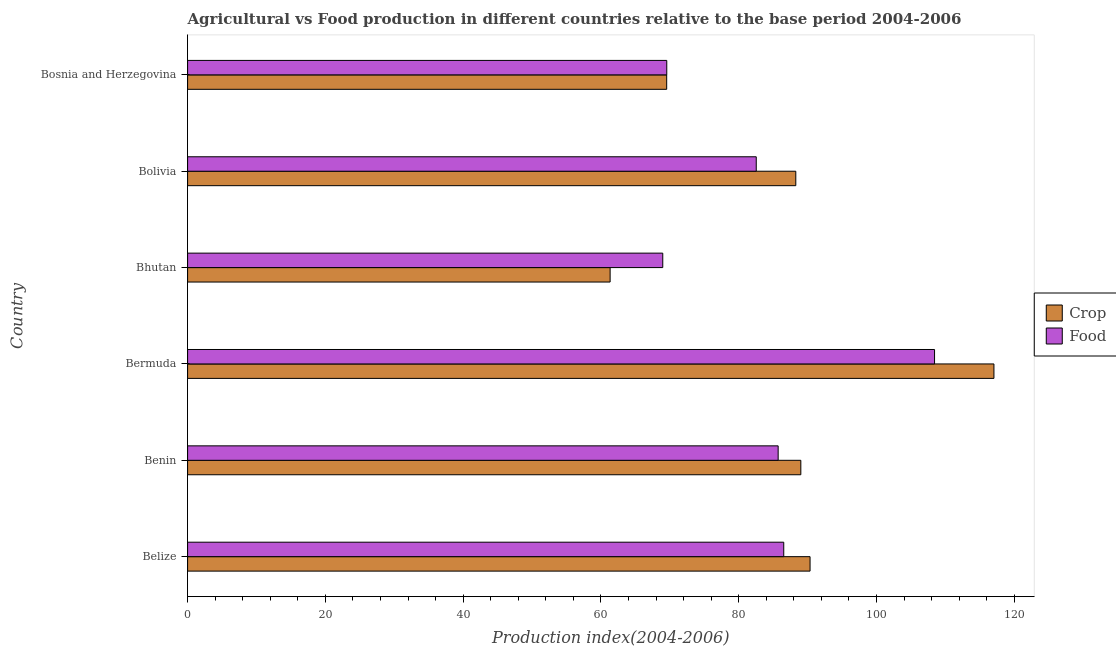How many different coloured bars are there?
Make the answer very short. 2. Are the number of bars on each tick of the Y-axis equal?
Offer a terse response. Yes. How many bars are there on the 4th tick from the top?
Make the answer very short. 2. What is the label of the 5th group of bars from the top?
Make the answer very short. Benin. What is the crop production index in Bermuda?
Make the answer very short. 117.04. Across all countries, what is the maximum crop production index?
Your response must be concise. 117.04. Across all countries, what is the minimum crop production index?
Make the answer very short. 61.33. In which country was the crop production index maximum?
Provide a short and direct response. Bermuda. In which country was the food production index minimum?
Ensure brevity in your answer.  Bhutan. What is the total crop production index in the graph?
Offer a very short reply. 515.55. What is the difference between the crop production index in Benin and that in Bhutan?
Provide a short and direct response. 27.68. What is the difference between the food production index in Benin and the crop production index in Bolivia?
Your response must be concise. -2.56. What is the average food production index per country?
Provide a succinct answer. 83.62. What is the difference between the crop production index and food production index in Bhutan?
Offer a terse response. -7.64. What is the ratio of the food production index in Benin to that in Bolivia?
Offer a terse response. 1.04. Is the crop production index in Benin less than that in Bolivia?
Make the answer very short. No. What is the difference between the highest and the second highest crop production index?
Provide a succinct answer. 26.69. What is the difference between the highest and the lowest crop production index?
Give a very brief answer. 55.71. What does the 1st bar from the top in Bolivia represents?
Ensure brevity in your answer.  Food. What does the 1st bar from the bottom in Benin represents?
Provide a short and direct response. Crop. Does the graph contain any zero values?
Offer a terse response. No. Does the graph contain grids?
Keep it short and to the point. No. Where does the legend appear in the graph?
Ensure brevity in your answer.  Center right. How many legend labels are there?
Offer a very short reply. 2. How are the legend labels stacked?
Offer a terse response. Vertical. What is the title of the graph?
Provide a short and direct response. Agricultural vs Food production in different countries relative to the base period 2004-2006. Does "Depositors" appear as one of the legend labels in the graph?
Offer a very short reply. No. What is the label or title of the X-axis?
Your answer should be very brief. Production index(2004-2006). What is the label or title of the Y-axis?
Make the answer very short. Country. What is the Production index(2004-2006) of Crop in Belize?
Ensure brevity in your answer.  90.35. What is the Production index(2004-2006) in Food in Belize?
Offer a very short reply. 86.53. What is the Production index(2004-2006) in Crop in Benin?
Keep it short and to the point. 89.01. What is the Production index(2004-2006) in Food in Benin?
Provide a succinct answer. 85.72. What is the Production index(2004-2006) of Crop in Bermuda?
Your answer should be very brief. 117.04. What is the Production index(2004-2006) of Food in Bermuda?
Your answer should be very brief. 108.42. What is the Production index(2004-2006) in Crop in Bhutan?
Provide a short and direct response. 61.33. What is the Production index(2004-2006) of Food in Bhutan?
Your answer should be very brief. 68.97. What is the Production index(2004-2006) of Crop in Bolivia?
Ensure brevity in your answer.  88.28. What is the Production index(2004-2006) of Food in Bolivia?
Your answer should be very brief. 82.54. What is the Production index(2004-2006) in Crop in Bosnia and Herzegovina?
Your response must be concise. 69.54. What is the Production index(2004-2006) in Food in Bosnia and Herzegovina?
Keep it short and to the point. 69.55. Across all countries, what is the maximum Production index(2004-2006) of Crop?
Keep it short and to the point. 117.04. Across all countries, what is the maximum Production index(2004-2006) of Food?
Your response must be concise. 108.42. Across all countries, what is the minimum Production index(2004-2006) in Crop?
Make the answer very short. 61.33. Across all countries, what is the minimum Production index(2004-2006) in Food?
Offer a terse response. 68.97. What is the total Production index(2004-2006) in Crop in the graph?
Keep it short and to the point. 515.55. What is the total Production index(2004-2006) in Food in the graph?
Provide a short and direct response. 501.73. What is the difference between the Production index(2004-2006) in Crop in Belize and that in Benin?
Your answer should be compact. 1.34. What is the difference between the Production index(2004-2006) of Food in Belize and that in Benin?
Make the answer very short. 0.81. What is the difference between the Production index(2004-2006) in Crop in Belize and that in Bermuda?
Offer a very short reply. -26.69. What is the difference between the Production index(2004-2006) in Food in Belize and that in Bermuda?
Offer a terse response. -21.89. What is the difference between the Production index(2004-2006) of Crop in Belize and that in Bhutan?
Provide a short and direct response. 29.02. What is the difference between the Production index(2004-2006) in Food in Belize and that in Bhutan?
Offer a very short reply. 17.56. What is the difference between the Production index(2004-2006) of Crop in Belize and that in Bolivia?
Provide a short and direct response. 2.07. What is the difference between the Production index(2004-2006) of Food in Belize and that in Bolivia?
Your response must be concise. 3.99. What is the difference between the Production index(2004-2006) of Crop in Belize and that in Bosnia and Herzegovina?
Provide a succinct answer. 20.81. What is the difference between the Production index(2004-2006) in Food in Belize and that in Bosnia and Herzegovina?
Your response must be concise. 16.98. What is the difference between the Production index(2004-2006) of Crop in Benin and that in Bermuda?
Provide a short and direct response. -28.03. What is the difference between the Production index(2004-2006) of Food in Benin and that in Bermuda?
Ensure brevity in your answer.  -22.7. What is the difference between the Production index(2004-2006) in Crop in Benin and that in Bhutan?
Offer a very short reply. 27.68. What is the difference between the Production index(2004-2006) of Food in Benin and that in Bhutan?
Give a very brief answer. 16.75. What is the difference between the Production index(2004-2006) of Crop in Benin and that in Bolivia?
Provide a succinct answer. 0.73. What is the difference between the Production index(2004-2006) of Food in Benin and that in Bolivia?
Make the answer very short. 3.18. What is the difference between the Production index(2004-2006) of Crop in Benin and that in Bosnia and Herzegovina?
Keep it short and to the point. 19.47. What is the difference between the Production index(2004-2006) of Food in Benin and that in Bosnia and Herzegovina?
Offer a very short reply. 16.17. What is the difference between the Production index(2004-2006) in Crop in Bermuda and that in Bhutan?
Make the answer very short. 55.71. What is the difference between the Production index(2004-2006) in Food in Bermuda and that in Bhutan?
Your answer should be very brief. 39.45. What is the difference between the Production index(2004-2006) of Crop in Bermuda and that in Bolivia?
Your response must be concise. 28.76. What is the difference between the Production index(2004-2006) in Food in Bermuda and that in Bolivia?
Your response must be concise. 25.88. What is the difference between the Production index(2004-2006) in Crop in Bermuda and that in Bosnia and Herzegovina?
Give a very brief answer. 47.5. What is the difference between the Production index(2004-2006) in Food in Bermuda and that in Bosnia and Herzegovina?
Your response must be concise. 38.87. What is the difference between the Production index(2004-2006) of Crop in Bhutan and that in Bolivia?
Provide a succinct answer. -26.95. What is the difference between the Production index(2004-2006) in Food in Bhutan and that in Bolivia?
Your response must be concise. -13.57. What is the difference between the Production index(2004-2006) in Crop in Bhutan and that in Bosnia and Herzegovina?
Ensure brevity in your answer.  -8.21. What is the difference between the Production index(2004-2006) in Food in Bhutan and that in Bosnia and Herzegovina?
Offer a very short reply. -0.58. What is the difference between the Production index(2004-2006) of Crop in Bolivia and that in Bosnia and Herzegovina?
Your answer should be compact. 18.74. What is the difference between the Production index(2004-2006) in Food in Bolivia and that in Bosnia and Herzegovina?
Keep it short and to the point. 12.99. What is the difference between the Production index(2004-2006) in Crop in Belize and the Production index(2004-2006) in Food in Benin?
Your response must be concise. 4.63. What is the difference between the Production index(2004-2006) of Crop in Belize and the Production index(2004-2006) of Food in Bermuda?
Make the answer very short. -18.07. What is the difference between the Production index(2004-2006) in Crop in Belize and the Production index(2004-2006) in Food in Bhutan?
Your response must be concise. 21.38. What is the difference between the Production index(2004-2006) in Crop in Belize and the Production index(2004-2006) in Food in Bolivia?
Offer a terse response. 7.81. What is the difference between the Production index(2004-2006) in Crop in Belize and the Production index(2004-2006) in Food in Bosnia and Herzegovina?
Give a very brief answer. 20.8. What is the difference between the Production index(2004-2006) of Crop in Benin and the Production index(2004-2006) of Food in Bermuda?
Your response must be concise. -19.41. What is the difference between the Production index(2004-2006) of Crop in Benin and the Production index(2004-2006) of Food in Bhutan?
Your answer should be very brief. 20.04. What is the difference between the Production index(2004-2006) of Crop in Benin and the Production index(2004-2006) of Food in Bolivia?
Provide a succinct answer. 6.47. What is the difference between the Production index(2004-2006) of Crop in Benin and the Production index(2004-2006) of Food in Bosnia and Herzegovina?
Your response must be concise. 19.46. What is the difference between the Production index(2004-2006) in Crop in Bermuda and the Production index(2004-2006) in Food in Bhutan?
Your answer should be compact. 48.07. What is the difference between the Production index(2004-2006) in Crop in Bermuda and the Production index(2004-2006) in Food in Bolivia?
Offer a terse response. 34.5. What is the difference between the Production index(2004-2006) in Crop in Bermuda and the Production index(2004-2006) in Food in Bosnia and Herzegovina?
Your response must be concise. 47.49. What is the difference between the Production index(2004-2006) in Crop in Bhutan and the Production index(2004-2006) in Food in Bolivia?
Your answer should be very brief. -21.21. What is the difference between the Production index(2004-2006) of Crop in Bhutan and the Production index(2004-2006) of Food in Bosnia and Herzegovina?
Offer a very short reply. -8.22. What is the difference between the Production index(2004-2006) in Crop in Bolivia and the Production index(2004-2006) in Food in Bosnia and Herzegovina?
Your answer should be very brief. 18.73. What is the average Production index(2004-2006) of Crop per country?
Make the answer very short. 85.92. What is the average Production index(2004-2006) of Food per country?
Offer a very short reply. 83.62. What is the difference between the Production index(2004-2006) of Crop and Production index(2004-2006) of Food in Belize?
Offer a terse response. 3.82. What is the difference between the Production index(2004-2006) of Crop and Production index(2004-2006) of Food in Benin?
Provide a short and direct response. 3.29. What is the difference between the Production index(2004-2006) in Crop and Production index(2004-2006) in Food in Bermuda?
Offer a very short reply. 8.62. What is the difference between the Production index(2004-2006) in Crop and Production index(2004-2006) in Food in Bhutan?
Provide a succinct answer. -7.64. What is the difference between the Production index(2004-2006) in Crop and Production index(2004-2006) in Food in Bolivia?
Offer a very short reply. 5.74. What is the difference between the Production index(2004-2006) of Crop and Production index(2004-2006) of Food in Bosnia and Herzegovina?
Make the answer very short. -0.01. What is the ratio of the Production index(2004-2006) of Crop in Belize to that in Benin?
Keep it short and to the point. 1.02. What is the ratio of the Production index(2004-2006) of Food in Belize to that in Benin?
Give a very brief answer. 1.01. What is the ratio of the Production index(2004-2006) of Crop in Belize to that in Bermuda?
Your answer should be very brief. 0.77. What is the ratio of the Production index(2004-2006) in Food in Belize to that in Bermuda?
Provide a short and direct response. 0.8. What is the ratio of the Production index(2004-2006) in Crop in Belize to that in Bhutan?
Ensure brevity in your answer.  1.47. What is the ratio of the Production index(2004-2006) in Food in Belize to that in Bhutan?
Provide a succinct answer. 1.25. What is the ratio of the Production index(2004-2006) of Crop in Belize to that in Bolivia?
Your answer should be very brief. 1.02. What is the ratio of the Production index(2004-2006) of Food in Belize to that in Bolivia?
Make the answer very short. 1.05. What is the ratio of the Production index(2004-2006) of Crop in Belize to that in Bosnia and Herzegovina?
Keep it short and to the point. 1.3. What is the ratio of the Production index(2004-2006) of Food in Belize to that in Bosnia and Herzegovina?
Ensure brevity in your answer.  1.24. What is the ratio of the Production index(2004-2006) of Crop in Benin to that in Bermuda?
Keep it short and to the point. 0.76. What is the ratio of the Production index(2004-2006) of Food in Benin to that in Bermuda?
Make the answer very short. 0.79. What is the ratio of the Production index(2004-2006) in Crop in Benin to that in Bhutan?
Ensure brevity in your answer.  1.45. What is the ratio of the Production index(2004-2006) of Food in Benin to that in Bhutan?
Ensure brevity in your answer.  1.24. What is the ratio of the Production index(2004-2006) of Crop in Benin to that in Bolivia?
Offer a very short reply. 1.01. What is the ratio of the Production index(2004-2006) in Crop in Benin to that in Bosnia and Herzegovina?
Your answer should be very brief. 1.28. What is the ratio of the Production index(2004-2006) in Food in Benin to that in Bosnia and Herzegovina?
Provide a short and direct response. 1.23. What is the ratio of the Production index(2004-2006) of Crop in Bermuda to that in Bhutan?
Provide a short and direct response. 1.91. What is the ratio of the Production index(2004-2006) in Food in Bermuda to that in Bhutan?
Make the answer very short. 1.57. What is the ratio of the Production index(2004-2006) in Crop in Bermuda to that in Bolivia?
Make the answer very short. 1.33. What is the ratio of the Production index(2004-2006) of Food in Bermuda to that in Bolivia?
Provide a short and direct response. 1.31. What is the ratio of the Production index(2004-2006) of Crop in Bermuda to that in Bosnia and Herzegovina?
Provide a short and direct response. 1.68. What is the ratio of the Production index(2004-2006) of Food in Bermuda to that in Bosnia and Herzegovina?
Your answer should be compact. 1.56. What is the ratio of the Production index(2004-2006) in Crop in Bhutan to that in Bolivia?
Provide a succinct answer. 0.69. What is the ratio of the Production index(2004-2006) in Food in Bhutan to that in Bolivia?
Make the answer very short. 0.84. What is the ratio of the Production index(2004-2006) in Crop in Bhutan to that in Bosnia and Herzegovina?
Keep it short and to the point. 0.88. What is the ratio of the Production index(2004-2006) of Crop in Bolivia to that in Bosnia and Herzegovina?
Your response must be concise. 1.27. What is the ratio of the Production index(2004-2006) in Food in Bolivia to that in Bosnia and Herzegovina?
Your response must be concise. 1.19. What is the difference between the highest and the second highest Production index(2004-2006) in Crop?
Your answer should be very brief. 26.69. What is the difference between the highest and the second highest Production index(2004-2006) in Food?
Your answer should be very brief. 21.89. What is the difference between the highest and the lowest Production index(2004-2006) in Crop?
Keep it short and to the point. 55.71. What is the difference between the highest and the lowest Production index(2004-2006) of Food?
Ensure brevity in your answer.  39.45. 